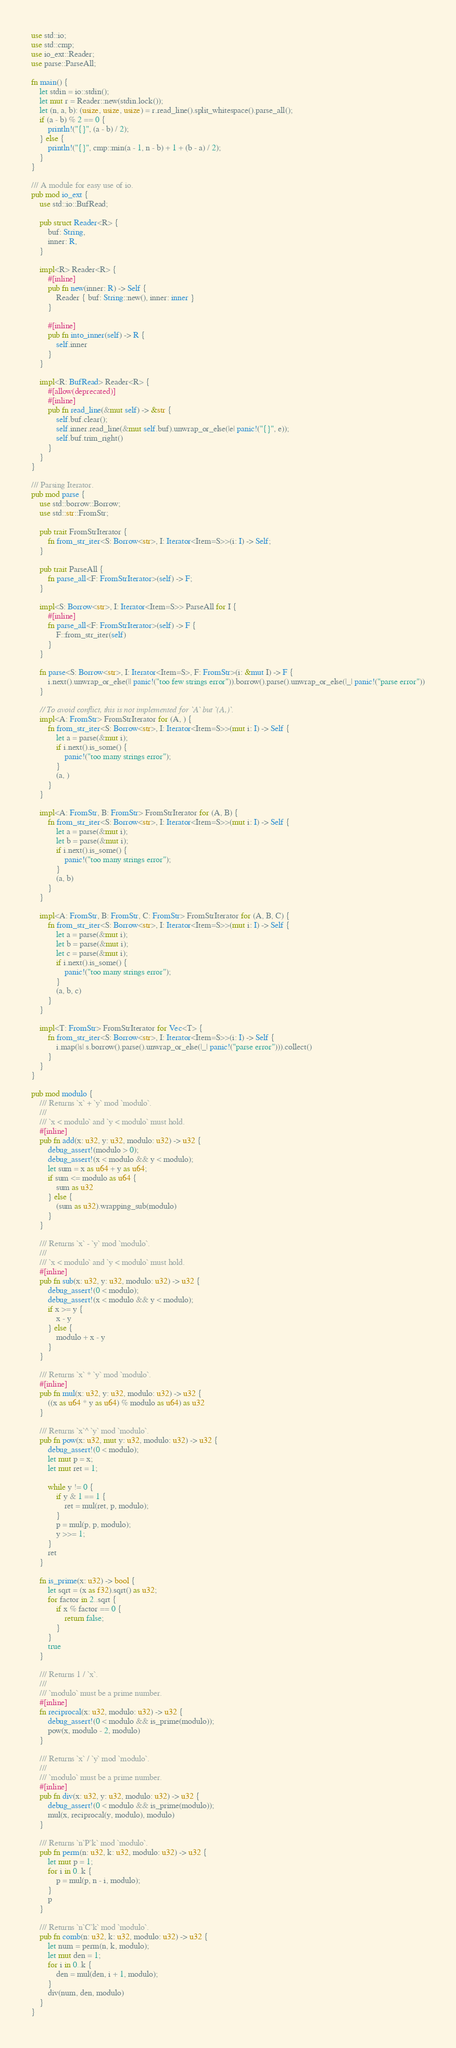<code> <loc_0><loc_0><loc_500><loc_500><_Rust_>use std::io;
use std::cmp;
use io_ext::Reader;
use parse::ParseAll;

fn main() {
    let stdin = io::stdin();
    let mut r = Reader::new(stdin.lock());
    let (n, a, b): (usize, usize, usize) = r.read_line().split_whitespace().parse_all();
    if (a - b) % 2 == 0 {
        println!("{}", (a - b) / 2);
    } else {
        println!("{}", cmp::min(a - 1, n - b) + 1 + (b - a) / 2);
    }
}

/// A module for easy use of io.
pub mod io_ext {
    use std::io::BufRead;

    pub struct Reader<R> {
        buf: String,
        inner: R,
    }

    impl<R> Reader<R> {
        #[inline]
        pub fn new(inner: R) -> Self {
            Reader { buf: String::new(), inner: inner }
        }

        #[inline]
        pub fn into_inner(self) -> R {
            self.inner
        }
    }

    impl<R: BufRead> Reader<R> {
        #[allow(deprecated)]
        #[inline]
        pub fn read_line(&mut self) -> &str {
            self.buf.clear();
            self.inner.read_line(&mut self.buf).unwrap_or_else(|e| panic!("{}", e));
            self.buf.trim_right()
        }
    }
}

/// Parsing Iterator.
pub mod parse {
    use std::borrow::Borrow;
    use std::str::FromStr;

    pub trait FromStrIterator {
        fn from_str_iter<S: Borrow<str>, I: Iterator<Item=S>>(i: I) -> Self;
    }

    pub trait ParseAll {
        fn parse_all<F: FromStrIterator>(self) -> F;
    }

    impl<S: Borrow<str>, I: Iterator<Item=S>> ParseAll for I {
        #[inline]
        fn parse_all<F: FromStrIterator>(self) -> F {
            F::from_str_iter(self)
        }
    }

    fn parse<S: Borrow<str>, I: Iterator<Item=S>, F: FromStr>(i: &mut I) -> F {
        i.next().unwrap_or_else(|| panic!("too few strings error")).borrow().parse().unwrap_or_else(|_| panic!("parse error"))
    }

    // To avoid conflict, this is not implemented for `A` but `(A,)`.
    impl<A: FromStr> FromStrIterator for (A, ) {
        fn from_str_iter<S: Borrow<str>, I: Iterator<Item=S>>(mut i: I) -> Self {
            let a = parse(&mut i);
            if i.next().is_some() {
                panic!("too many strings error");
            }
            (a, )
        }
    }

    impl<A: FromStr, B: FromStr> FromStrIterator for (A, B) {
        fn from_str_iter<S: Borrow<str>, I: Iterator<Item=S>>(mut i: I) -> Self {
            let a = parse(&mut i);
            let b = parse(&mut i);
            if i.next().is_some() {
                panic!("too many strings error");
            }
            (a, b)
        }
    }

    impl<A: FromStr, B: FromStr, C: FromStr> FromStrIterator for (A, B, C) {
        fn from_str_iter<S: Borrow<str>, I: Iterator<Item=S>>(mut i: I) -> Self {
            let a = parse(&mut i);
            let b = parse(&mut i);
            let c = parse(&mut i);
            if i.next().is_some() {
                panic!("too many strings error");
            }
            (a, b, c)
        }
    }

    impl<T: FromStr> FromStrIterator for Vec<T> {
        fn from_str_iter<S: Borrow<str>, I: Iterator<Item=S>>(i: I) -> Self {
            i.map(|s| s.borrow().parse().unwrap_or_else(|_| panic!("parse error"))).collect()
        }
    }
}

pub mod modulo {
    /// Returns `x` + `y` mod `modulo`.
    ///
    /// `x < modulo` and `y < modulo` must hold.
    #[inline]
    pub fn add(x: u32, y: u32, modulo: u32) -> u32 {
        debug_assert!(modulo > 0);
        debug_assert!(x < modulo && y < modulo);
        let sum = x as u64 + y as u64;
        if sum <= modulo as u64 {
            sum as u32
        } else {
            (sum as u32).wrapping_sub(modulo)
        }
    }

    /// Returns `x` - `y` mod `modulo`.
    ///
    /// `x < modulo` and `y < modulo` must hold.
    #[inline]
    pub fn sub(x: u32, y: u32, modulo: u32) -> u32 {
        debug_assert!(0 < modulo);
        debug_assert!(x < modulo && y < modulo);
        if x >= y {
            x - y
        } else {
            modulo + x - y
        }
    }

    /// Returns `x` * `y` mod `modulo`.
    #[inline]
    pub fn mul(x: u32, y: u32, modulo: u32) -> u32 {
        ((x as u64 * y as u64) % modulo as u64) as u32
    }

    /// Returns `x`^ `y` mod `modulo`.
    pub fn pow(x: u32, mut y: u32, modulo: u32) -> u32 {
        debug_assert!(0 < modulo);
        let mut p = x;
        let mut ret = 1;

        while y != 0 {
            if y & 1 == 1 {
                ret = mul(ret, p, modulo);
            }
            p = mul(p, p, modulo);
            y >>= 1;
        }
        ret
    }

    fn is_prime(x: u32) -> bool {
        let sqrt = (x as f32).sqrt() as u32;
        for factor in 2..sqrt {
            if x % factor == 0 {
                return false;
            }
        }
        true
    }

    /// Returns 1 / `x`.
    ///
    /// `modulo` must be a prime number.
    #[inline]
    fn reciprocal(x: u32, modulo: u32) -> u32 {
        debug_assert!(0 < modulo && is_prime(modulo));
        pow(x, modulo - 2, modulo)
    }

    /// Returns `x` / `y` mod `modulo`.
    ///
    /// `modulo` must be a prime number.
    #[inline]
    pub fn div(x: u32, y: u32, modulo: u32) -> u32 {
        debug_assert!(0 < modulo && is_prime(modulo));
        mul(x, reciprocal(y, modulo), modulo)
    }

    /// Returns `n`P`k` mod `modulo`.
    pub fn perm(n: u32, k: u32, modulo: u32) -> u32 {
        let mut p = 1;
        for i in 0..k {
            p = mul(p, n - i, modulo);
        }
        p
    }

    /// Returns `n`C`k` mod `modulo`.
    pub fn comb(n: u32, k: u32, modulo: u32) -> u32 {
        let num = perm(n, k, modulo);
        let mut den = 1;
        for i in 0..k {
            den = mul(den, i + 1, modulo);
        }
        div(num, den, modulo)
    }
}</code> 